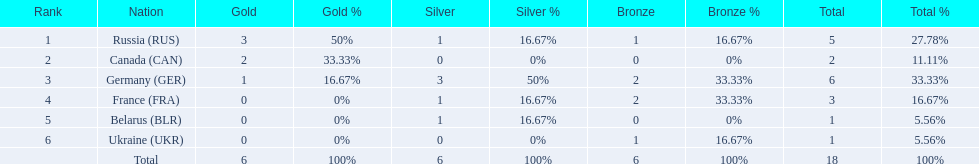Which nations participated? Russia (RUS), Canada (CAN), Germany (GER), France (FRA), Belarus (BLR), Ukraine (UKR). And how many gold medals did they win? 3, 2, 1, 0, 0, 0. What about silver medals? 1, 0, 3, 1, 1, 0. And bronze? 1, 0, 2, 2, 0, 1. Which nation only won gold medals? Canada (CAN). 